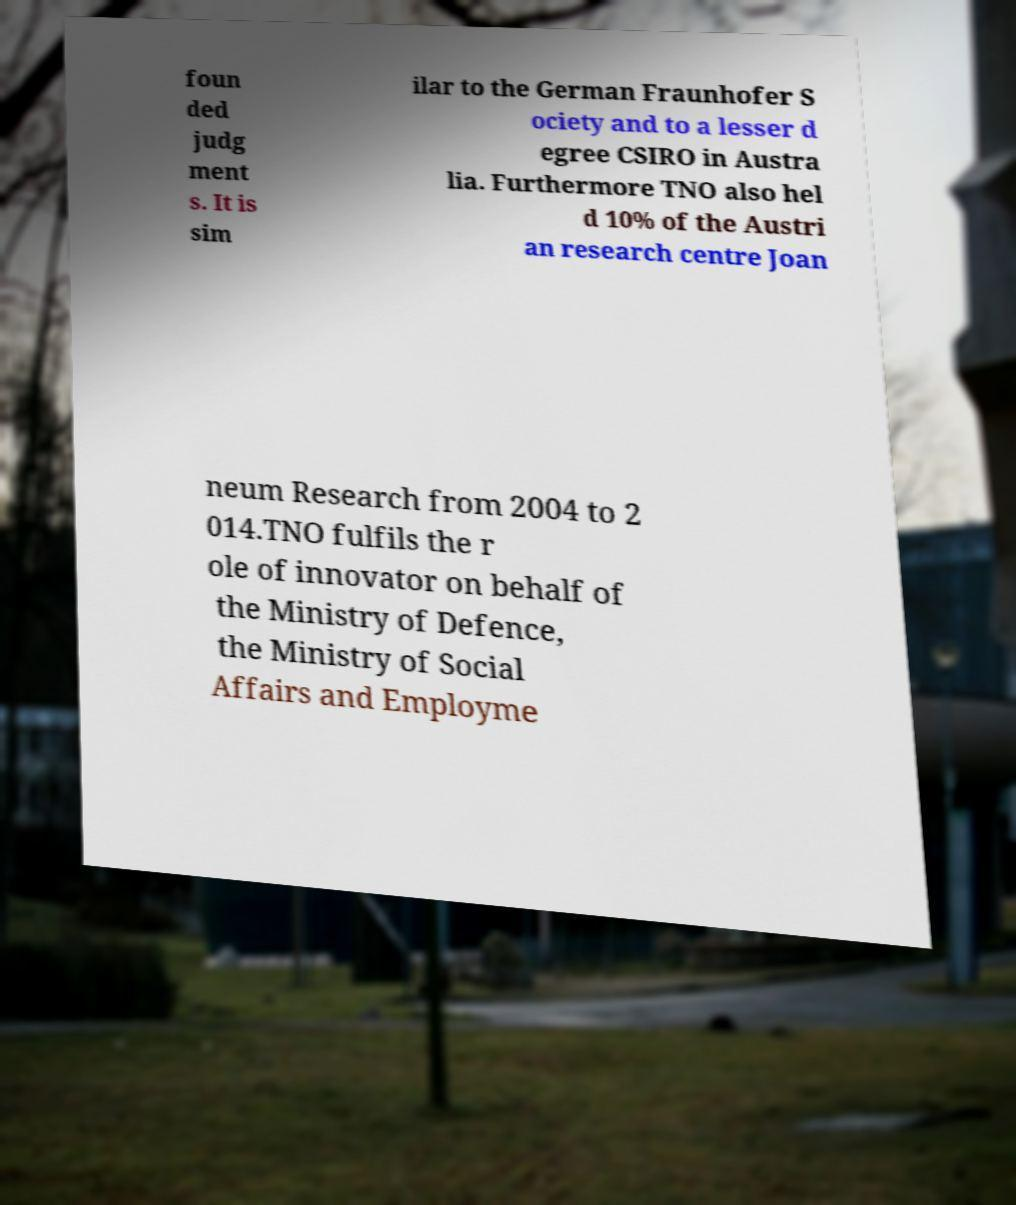Can you read and provide the text displayed in the image?This photo seems to have some interesting text. Can you extract and type it out for me? foun ded judg ment s. It is sim ilar to the German Fraunhofer S ociety and to a lesser d egree CSIRO in Austra lia. Furthermore TNO also hel d 10% of the Austri an research centre Joan neum Research from 2004 to 2 014.TNO fulfils the r ole of innovator on behalf of the Ministry of Defence, the Ministry of Social Affairs and Employme 